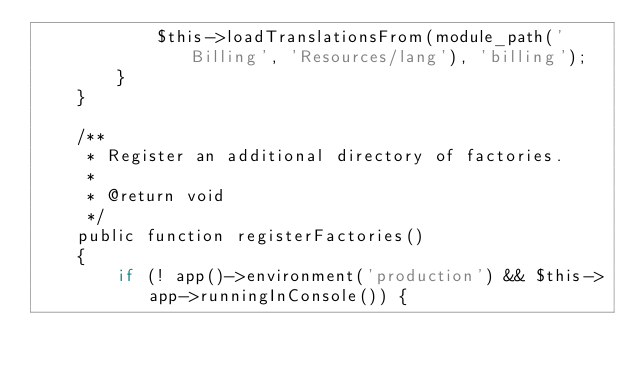Convert code to text. <code><loc_0><loc_0><loc_500><loc_500><_PHP_>            $this->loadTranslationsFrom(module_path('Billing', 'Resources/lang'), 'billing');
        }
    }

    /**
     * Register an additional directory of factories.
     *
     * @return void
     */
    public function registerFactories()
    {
        if (! app()->environment('production') && $this->app->runningInConsole()) {</code> 